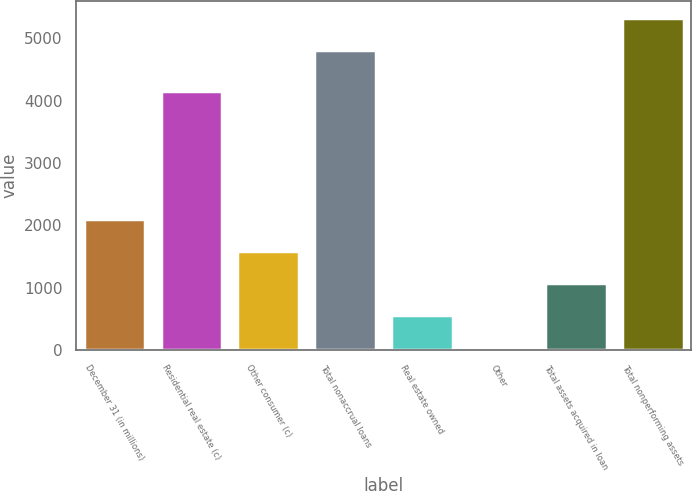Convert chart. <chart><loc_0><loc_0><loc_500><loc_500><bar_chart><fcel>December 31 (in millions)<fcel>Residential real estate (c)<fcel>Other consumer (c)<fcel>Total nonaccrual loans<fcel>Real estate owned<fcel>Other<fcel>Total assets acquired in loan<fcel>Total nonperforming assets<nl><fcel>2101.8<fcel>4154<fcel>1590.6<fcel>4820<fcel>568.2<fcel>57<fcel>1079.4<fcel>5331.2<nl></chart> 